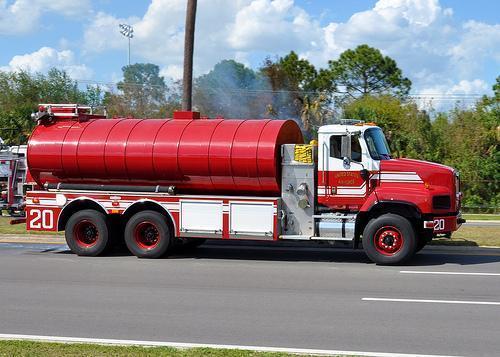How many trucks are in the street?
Give a very brief answer. 1. 